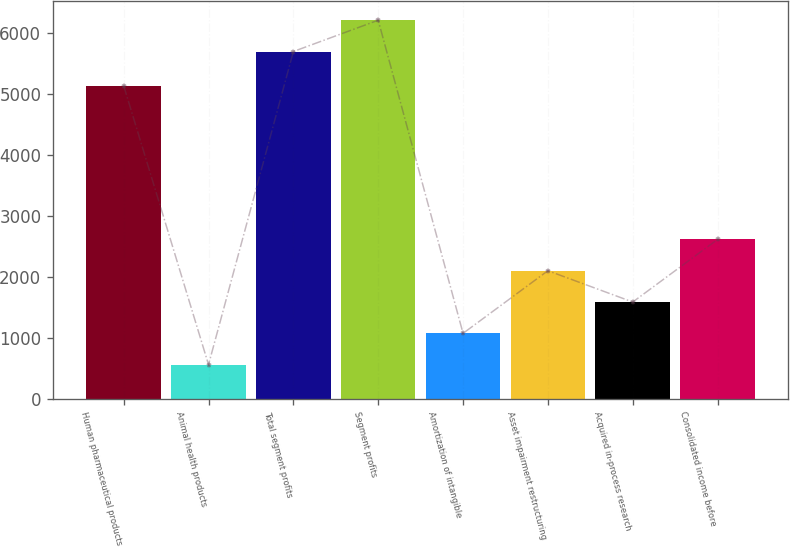<chart> <loc_0><loc_0><loc_500><loc_500><bar_chart><fcel>Human pharmaceutical products<fcel>Animal health products<fcel>Total segment profits<fcel>Segment profits<fcel>Amortization of intangible<fcel>Asset impairment restructuring<fcel>Acquired in-process research<fcel>Consolidated income before<nl><fcel>5139.7<fcel>561.3<fcel>5701<fcel>6214.97<fcel>1075.27<fcel>2103.21<fcel>1589.24<fcel>2617.18<nl></chart> 